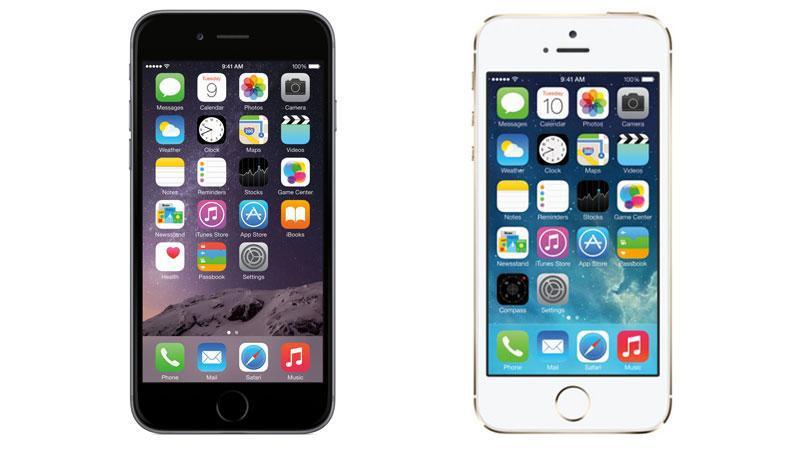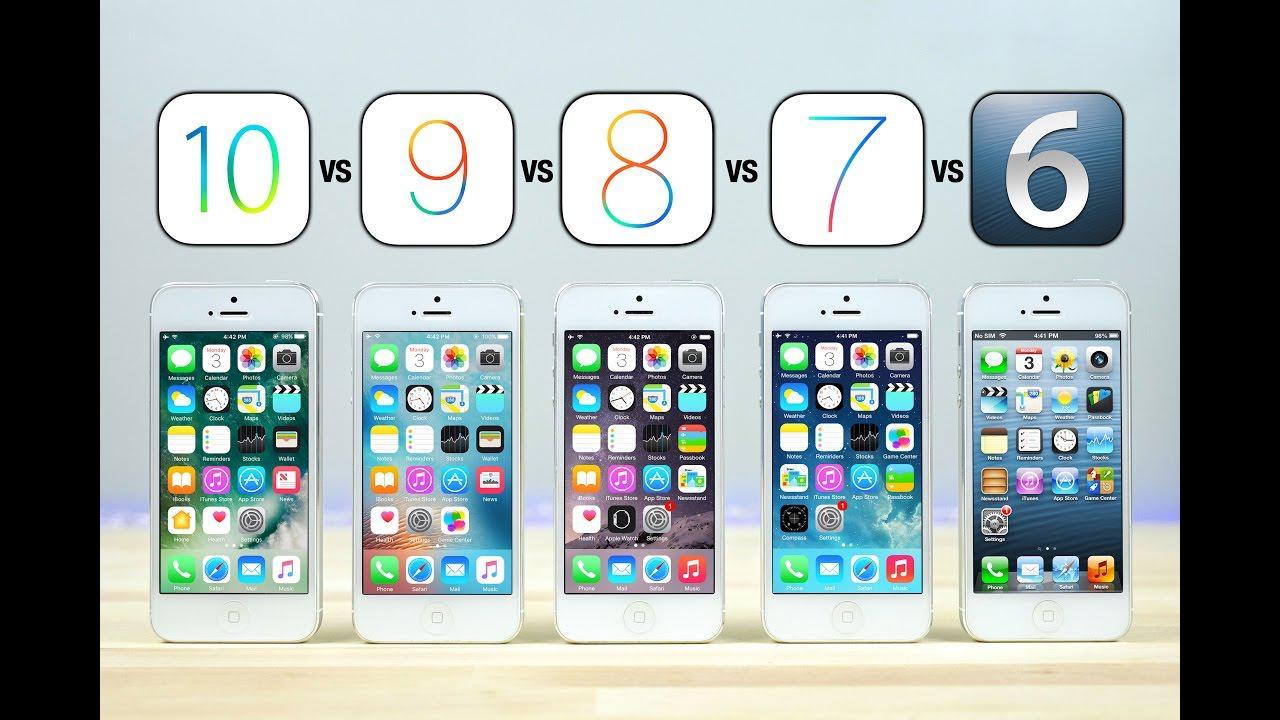The first image is the image on the left, the second image is the image on the right. For the images shown, is this caption "There are more phones in the image on the left." true? Answer yes or no. No. 